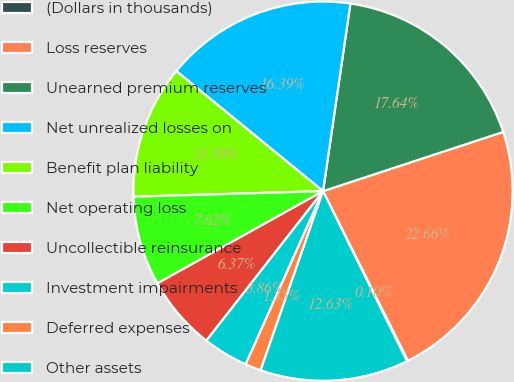Convert chart to OTSL. <chart><loc_0><loc_0><loc_500><loc_500><pie_chart><fcel>(Dollars in thousands)<fcel>Loss reserves<fcel>Unearned premium reserves<fcel>Net unrealized losses on<fcel>Benefit plan liability<fcel>Net operating loss<fcel>Uncollectible reinsurance<fcel>Investment impairments<fcel>Deferred expenses<fcel>Other assets<nl><fcel>0.1%<fcel>22.66%<fcel>17.64%<fcel>16.39%<fcel>11.38%<fcel>7.62%<fcel>6.37%<fcel>3.86%<fcel>1.35%<fcel>12.63%<nl></chart> 